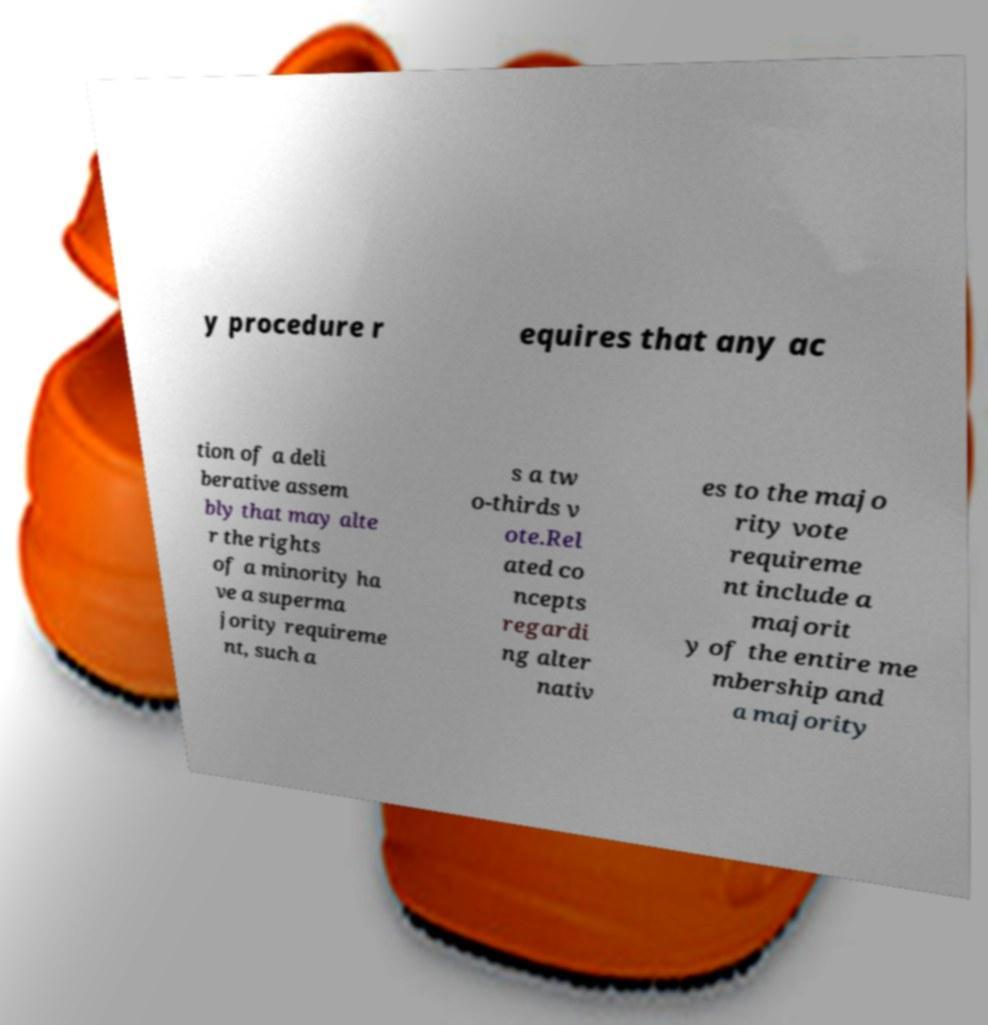Can you accurately transcribe the text from the provided image for me? y procedure r equires that any ac tion of a deli berative assem bly that may alte r the rights of a minority ha ve a superma jority requireme nt, such a s a tw o-thirds v ote.Rel ated co ncepts regardi ng alter nativ es to the majo rity vote requireme nt include a majorit y of the entire me mbership and a majority 